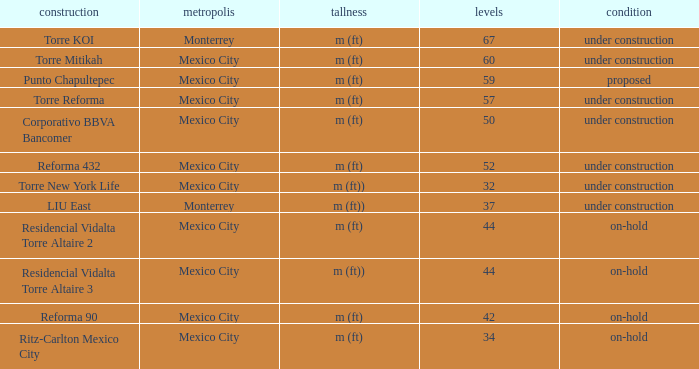How tall is the 52 story building? M (ft). 